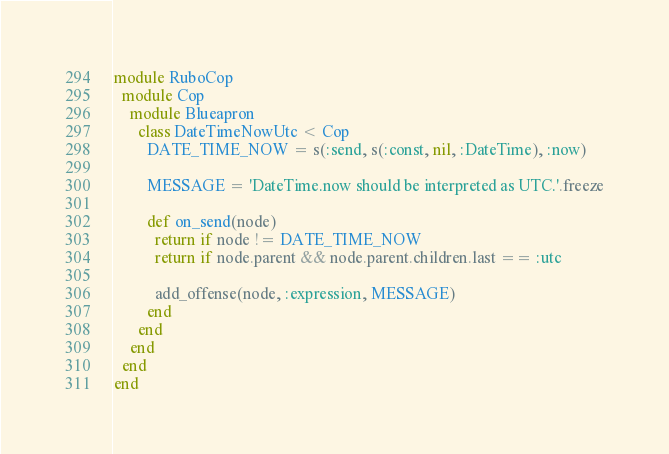<code> <loc_0><loc_0><loc_500><loc_500><_Ruby_>module RuboCop
  module Cop
    module Blueapron
      class DateTimeNowUtc < Cop
        DATE_TIME_NOW = s(:send, s(:const, nil, :DateTime), :now)

        MESSAGE = 'DateTime.now should be interpreted as UTC.'.freeze

        def on_send(node)
          return if node != DATE_TIME_NOW
          return if node.parent && node.parent.children.last == :utc

          add_offense(node, :expression, MESSAGE)
        end
      end
    end
  end
end
</code> 